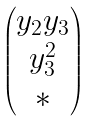<formula> <loc_0><loc_0><loc_500><loc_500>\begin{pmatrix} y _ { 2 } y _ { 3 } \\ y _ { 3 } ^ { 2 } \\ * \end{pmatrix}</formula> 